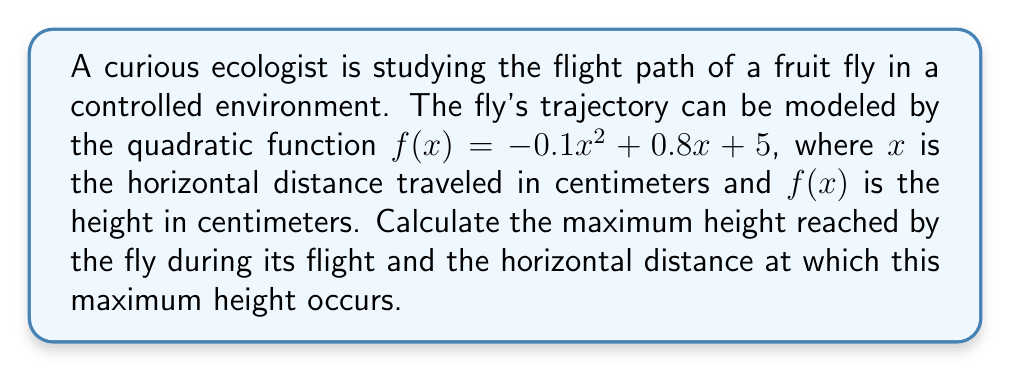Can you solve this math problem? To solve this problem, we need to follow these steps:

1) The quadratic function is in the form $f(x) = ax^2 + bx + c$, where:
   $a = -0.1$
   $b = 0.8$
   $c = 5$

2) For a quadratic function, the x-coordinate of the vertex represents the horizontal distance at which the maximum height occurs. This can be calculated using the formula:

   $x = -\frac{b}{2a}$

3) Substituting our values:

   $x = -\frac{0.8}{2(-0.1)} = -\frac{0.8}{-0.2} = 4$

4) To find the maximum height, we need to calculate $f(4)$:

   $f(4) = -0.1(4)^2 + 0.8(4) + 5$
   $    = -0.1(16) + 3.2 + 5$
   $    = -1.6 + 3.2 + 5$
   $    = 6.6$

Therefore, the maximum height is reached when the fly has traveled 4 cm horizontally, and the maximum height is 6.6 cm.
Answer: The fly reaches its maximum height of 6.6 cm when it has traveled 4 cm horizontally. 